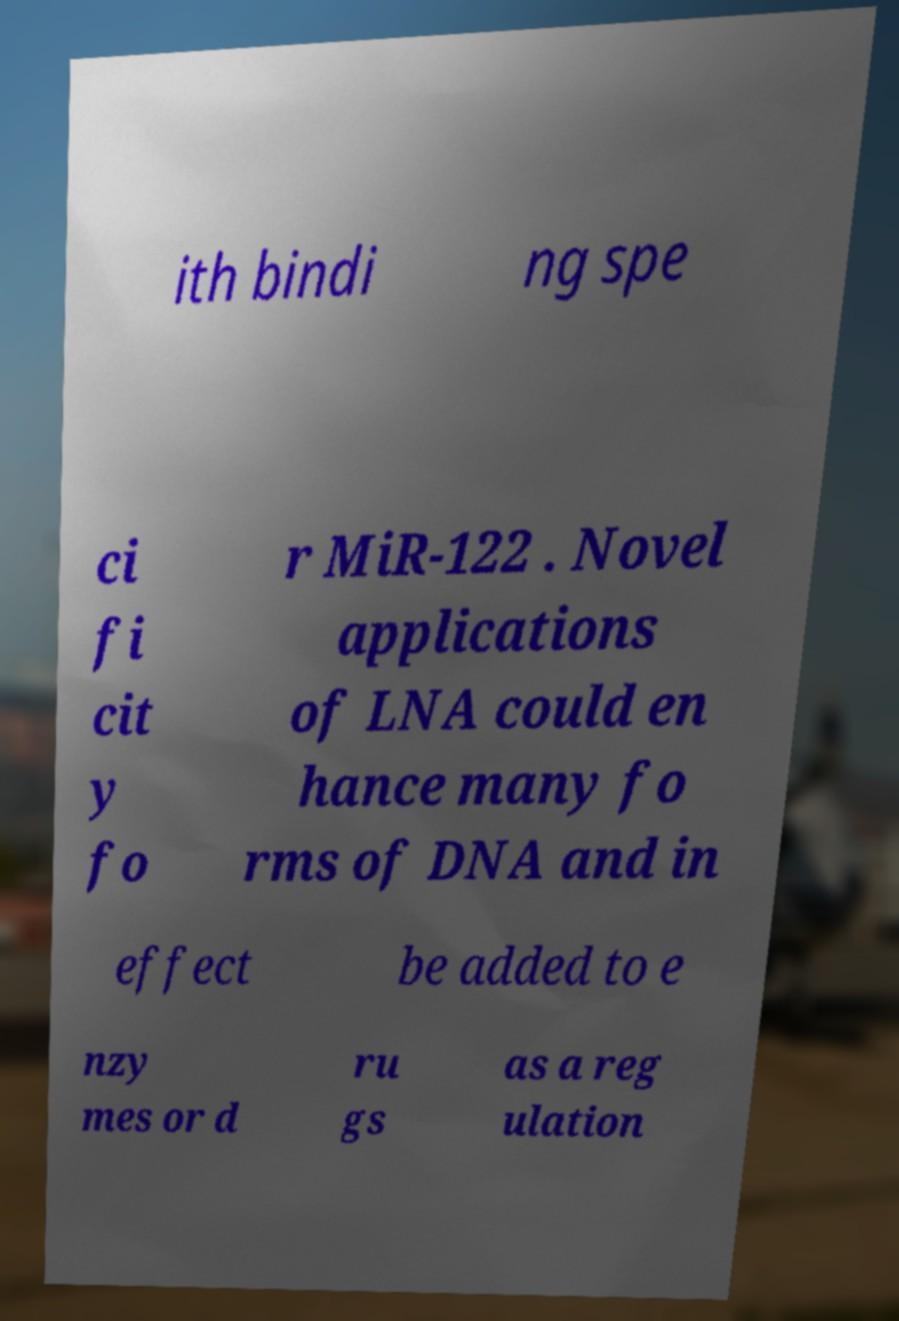There's text embedded in this image that I need extracted. Can you transcribe it verbatim? ith bindi ng spe ci fi cit y fo r MiR-122 . Novel applications of LNA could en hance many fo rms of DNA and in effect be added to e nzy mes or d ru gs as a reg ulation 